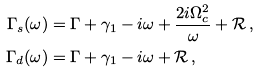<formula> <loc_0><loc_0><loc_500><loc_500>\Gamma _ { s } ( \omega ) & = \Gamma + \gamma _ { 1 } - i \omega + \frac { 2 i \Omega _ { c } ^ { 2 } } { \omega } + { \mathcal { R } } \, , \\ \Gamma _ { d } ( \omega ) & = \Gamma + \gamma _ { 1 } - i \omega + { \mathcal { R } } \, ,</formula> 